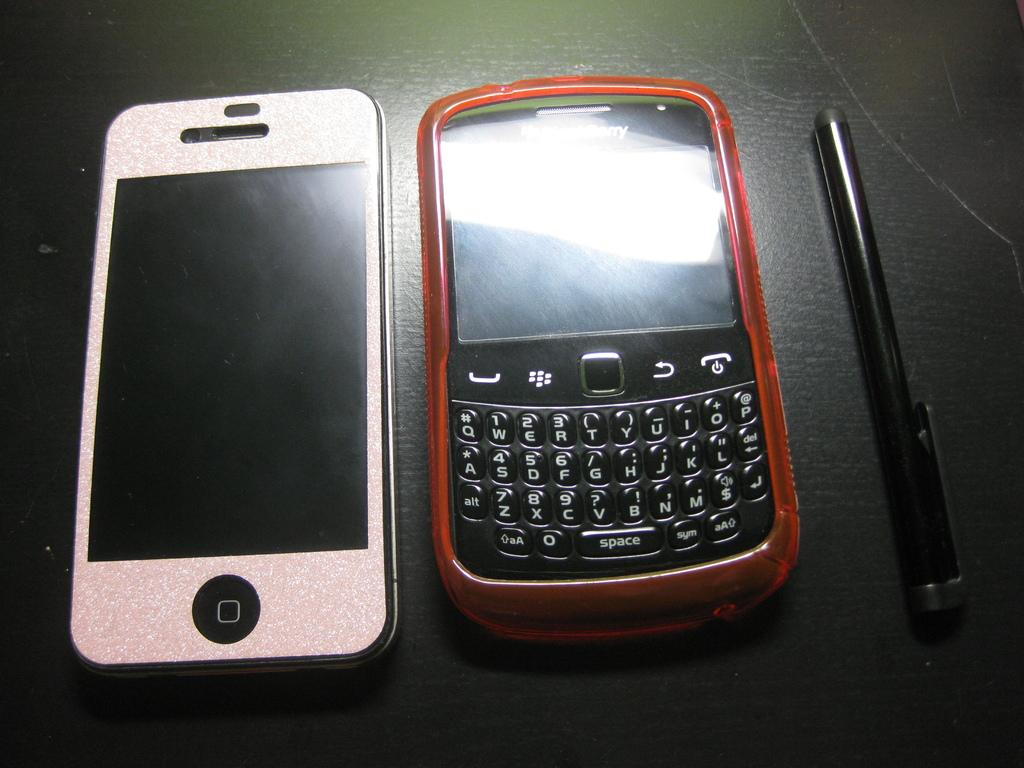<image>
Write a terse but informative summary of the picture. Standard QWERTY keys are shown on this Blackberry device. 